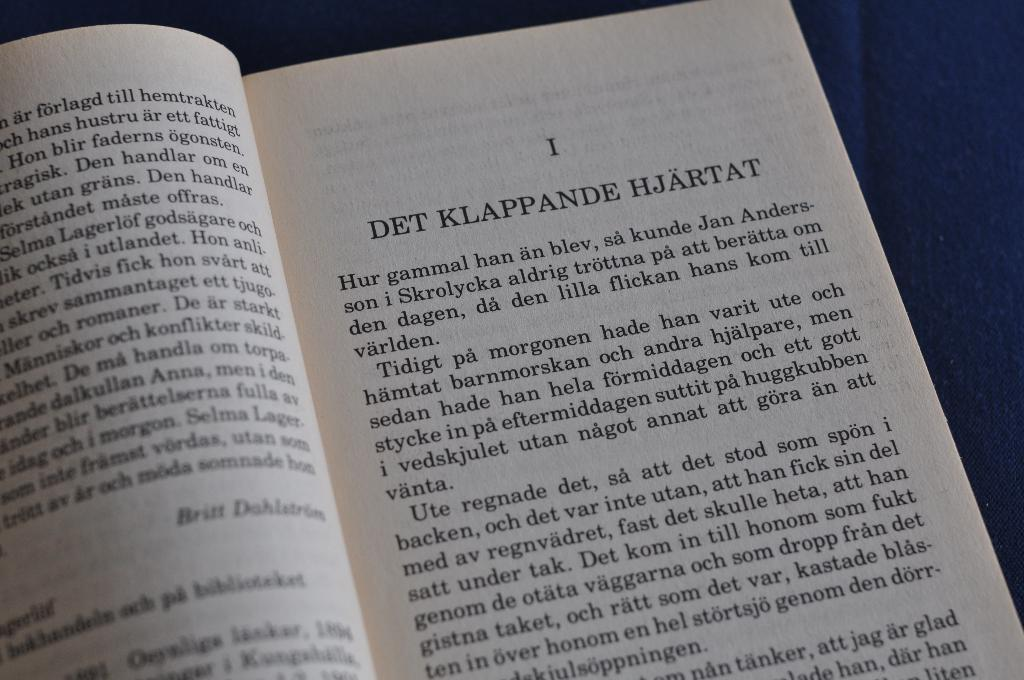<image>
Present a compact description of the photo's key features. Chapter 1 of a book that says DET KLAPPANDE HJARTAT. 